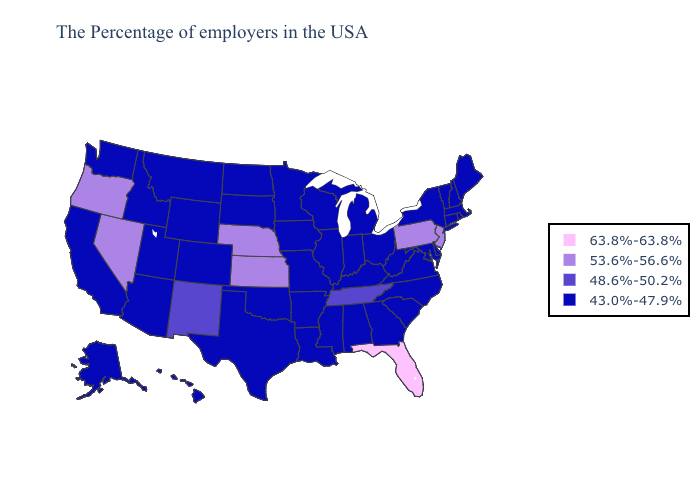Among the states that border Kentucky , which have the highest value?
Keep it brief. Tennessee. What is the lowest value in states that border Pennsylvania?
Concise answer only. 43.0%-47.9%. Name the states that have a value in the range 63.8%-63.8%?
Keep it brief. Florida. Does Oregon have the lowest value in the USA?
Short answer required. No. Does the map have missing data?
Be succinct. No. Does the map have missing data?
Be succinct. No. Which states have the highest value in the USA?
Concise answer only. Florida. What is the highest value in the USA?
Short answer required. 63.8%-63.8%. What is the highest value in the USA?
Answer briefly. 63.8%-63.8%. What is the highest value in states that border South Dakota?
Give a very brief answer. 53.6%-56.6%. What is the value of Nevada?
Concise answer only. 53.6%-56.6%. Does the map have missing data?
Give a very brief answer. No. Which states hav the highest value in the West?
Give a very brief answer. Nevada, Oregon. What is the value of Wyoming?
Be succinct. 43.0%-47.9%. What is the lowest value in the USA?
Keep it brief. 43.0%-47.9%. 